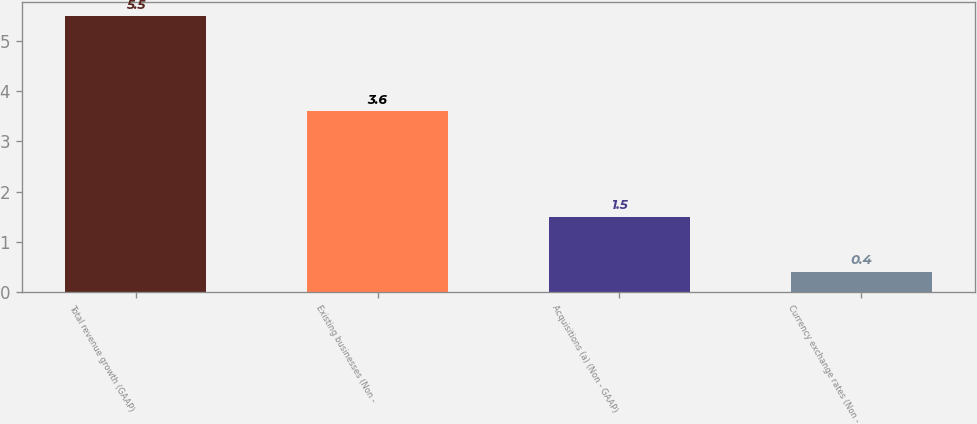<chart> <loc_0><loc_0><loc_500><loc_500><bar_chart><fcel>Total revenue growth (GAAP)<fcel>Existing businesses (Non -<fcel>Acquisitions (a) (Non - GAAP)<fcel>Currency exchange rates (Non -<nl><fcel>5.5<fcel>3.6<fcel>1.5<fcel>0.4<nl></chart> 